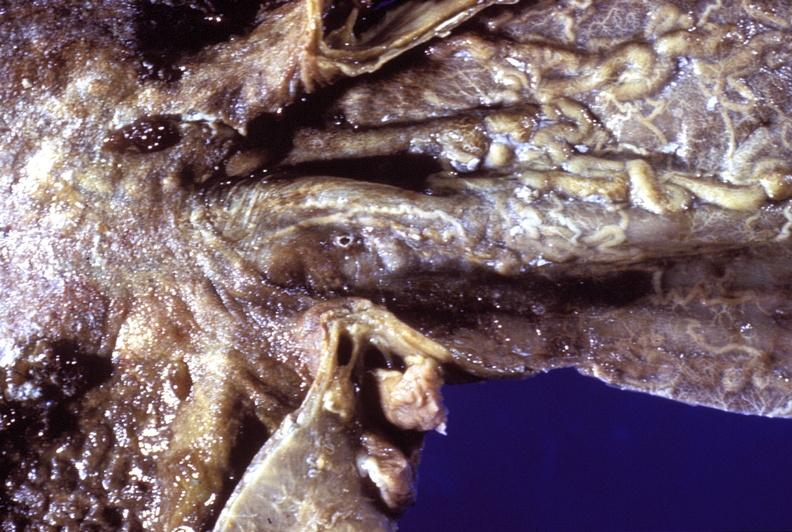does this image show esophagus, esophogeal varices?
Answer the question using a single word or phrase. Yes 